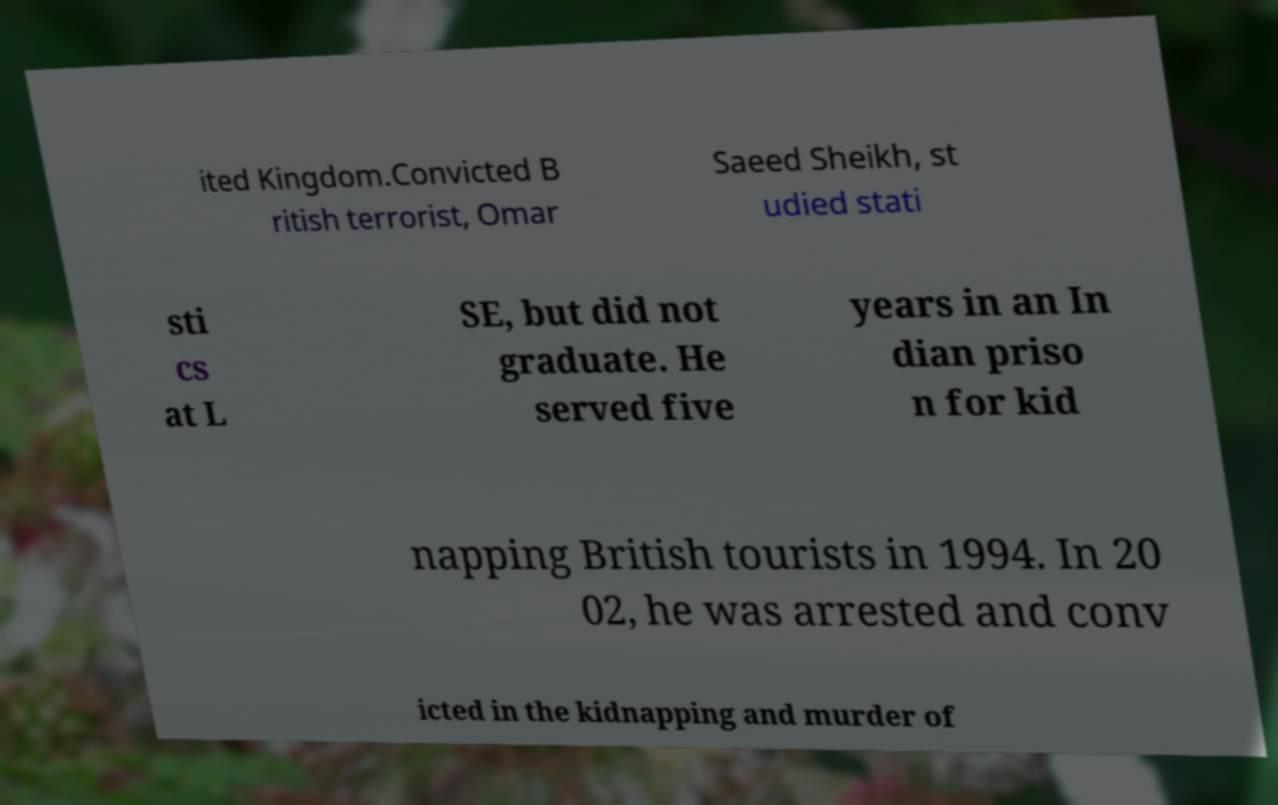There's text embedded in this image that I need extracted. Can you transcribe it verbatim? ited Kingdom.Convicted B ritish terrorist, Omar Saeed Sheikh, st udied stati sti cs at L SE, but did not graduate. He served five years in an In dian priso n for kid napping British tourists in 1994. In 20 02, he was arrested and conv icted in the kidnapping and murder of 